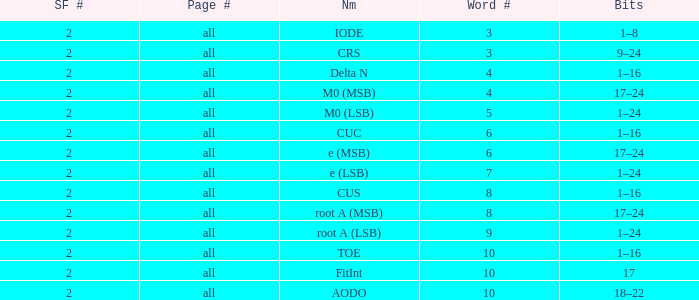What is the total subframe count with Bits of 18–22? 2.0. 